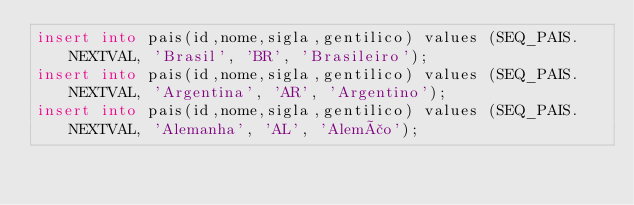<code> <loc_0><loc_0><loc_500><loc_500><_SQL_>insert into pais(id,nome,sigla,gentilico) values (SEQ_PAIS.NEXTVAL, 'Brasil', 'BR', 'Brasileiro'); 
insert into pais(id,nome,sigla,gentilico) values (SEQ_PAIS.NEXTVAL, 'Argentina', 'AR', 'Argentino'); 
insert into pais(id,nome,sigla,gentilico) values (SEQ_PAIS.NEXTVAL, 'Alemanha', 'AL', 'Alemão'); 
 </code> 